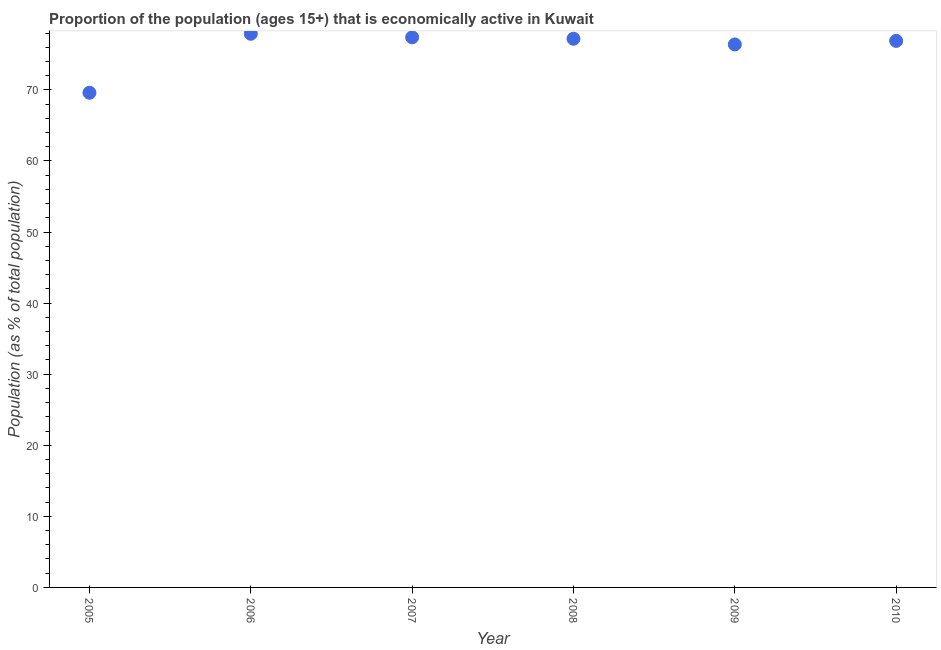What is the percentage of economically active population in 2007?
Your answer should be compact. 77.4. Across all years, what is the maximum percentage of economically active population?
Provide a short and direct response. 77.9. Across all years, what is the minimum percentage of economically active population?
Provide a short and direct response. 69.6. In which year was the percentage of economically active population minimum?
Your answer should be very brief. 2005. What is the sum of the percentage of economically active population?
Ensure brevity in your answer.  455.4. What is the difference between the percentage of economically active population in 2005 and 2006?
Your response must be concise. -8.3. What is the average percentage of economically active population per year?
Give a very brief answer. 75.9. What is the median percentage of economically active population?
Provide a succinct answer. 77.05. Do a majority of the years between 2009 and 2010 (inclusive) have percentage of economically active population greater than 74 %?
Keep it short and to the point. Yes. What is the ratio of the percentage of economically active population in 2006 to that in 2008?
Give a very brief answer. 1.01. Is the percentage of economically active population in 2008 less than that in 2009?
Provide a succinct answer. No. Is the difference between the percentage of economically active population in 2007 and 2008 greater than the difference between any two years?
Make the answer very short. No. What is the difference between the highest and the second highest percentage of economically active population?
Ensure brevity in your answer.  0.5. What is the difference between the highest and the lowest percentage of economically active population?
Keep it short and to the point. 8.3. In how many years, is the percentage of economically active population greater than the average percentage of economically active population taken over all years?
Your response must be concise. 5. Does the percentage of economically active population monotonically increase over the years?
Your answer should be compact. No. How many years are there in the graph?
Ensure brevity in your answer.  6. What is the title of the graph?
Your answer should be compact. Proportion of the population (ages 15+) that is economically active in Kuwait. What is the label or title of the X-axis?
Keep it short and to the point. Year. What is the label or title of the Y-axis?
Keep it short and to the point. Population (as % of total population). What is the Population (as % of total population) in 2005?
Ensure brevity in your answer.  69.6. What is the Population (as % of total population) in 2006?
Provide a succinct answer. 77.9. What is the Population (as % of total population) in 2007?
Ensure brevity in your answer.  77.4. What is the Population (as % of total population) in 2008?
Ensure brevity in your answer.  77.2. What is the Population (as % of total population) in 2009?
Provide a short and direct response. 76.4. What is the Population (as % of total population) in 2010?
Your answer should be compact. 76.9. What is the difference between the Population (as % of total population) in 2005 and 2007?
Give a very brief answer. -7.8. What is the difference between the Population (as % of total population) in 2006 and 2010?
Offer a very short reply. 1. What is the difference between the Population (as % of total population) in 2007 and 2009?
Ensure brevity in your answer.  1. What is the difference between the Population (as % of total population) in 2007 and 2010?
Your answer should be very brief. 0.5. What is the ratio of the Population (as % of total population) in 2005 to that in 2006?
Provide a short and direct response. 0.89. What is the ratio of the Population (as % of total population) in 2005 to that in 2007?
Offer a very short reply. 0.9. What is the ratio of the Population (as % of total population) in 2005 to that in 2008?
Give a very brief answer. 0.9. What is the ratio of the Population (as % of total population) in 2005 to that in 2009?
Give a very brief answer. 0.91. What is the ratio of the Population (as % of total population) in 2005 to that in 2010?
Your answer should be compact. 0.91. What is the ratio of the Population (as % of total population) in 2006 to that in 2009?
Your answer should be compact. 1.02. What is the ratio of the Population (as % of total population) in 2007 to that in 2009?
Keep it short and to the point. 1.01. What is the ratio of the Population (as % of total population) in 2007 to that in 2010?
Ensure brevity in your answer.  1.01. What is the ratio of the Population (as % of total population) in 2009 to that in 2010?
Your response must be concise. 0.99. 